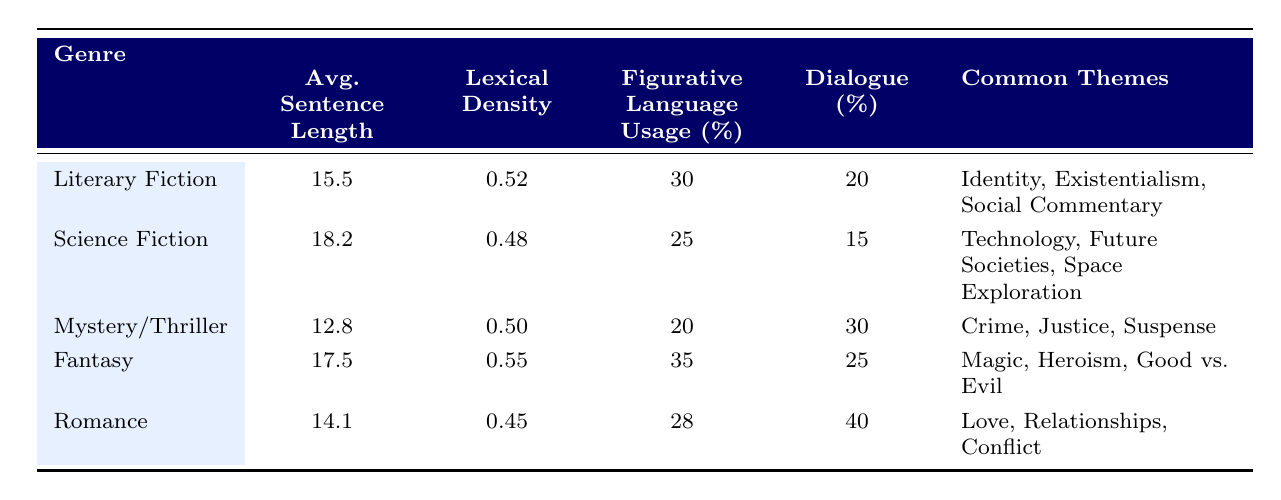What is the average sentence length in Literary Fiction? The table shows the row for Literary Fiction, from which we can directly retrieve the value in the Average Sentence Length column. It is stated as 15.5.
Answer: 15.5 Which genre has the highest percentage of dialogue? The dialogue percentages are provided for each genre. By examining these values, we see that Romance has the highest percentage at 40.
Answer: 40 What is the average lexical density of Fantasy and Mystery/Thriller combined? Lexical density for Fantasy is 0.55 and for Mystery/Thriller it is 0.50. To find the average, add these two values: 0.55 + 0.50 = 1.05, then divide by 2, resulting in 1.05 / 2 = 0.525.
Answer: 0.525 Is the average sentence length for Science Fiction greater than that for Romance? The average sentence length for Science Fiction is 18.2, while for Romance it is 14.1. Since 18.2 is greater than 14.1, the statement is true.
Answer: Yes Which genre has the least lexical density? By comparing the lexical densities across all genres, we see that Romance has the lowest value at 0.45.
Answer: 0.45 What is the total figurative language usage percentage across all the genres? To find the total, we add the figurative language percentages: 30 + 25 + 20 + 35 + 28 = 168.
Answer: 168 What common themes are present in both Literary Fiction and Fantasy? By reviewing the common themes listed for each genre, Literary Fiction includes Identity, Existentialism, and Social Commentary, while Fantasy lists Magic, Heroism, and Good vs. Evil. There are no overlapping themes between the two genres.
Answer: None Which genre features "Technology" as a common theme? Referring to the common themes in the table, we find that Technology is specifically listed under Science Fiction.
Answer: Science Fiction Is it true that all genres have more than 20% figurative language usage? The percentages for figurative language usage are 30 (Literary Fiction), 25 (Science Fiction), 20 (Mystery/Thriller), 35 (Fantasy), and 28 (Romance). Mystery/Thriller has exactly 20%, which means not all genres exceed 20%.
Answer: No 